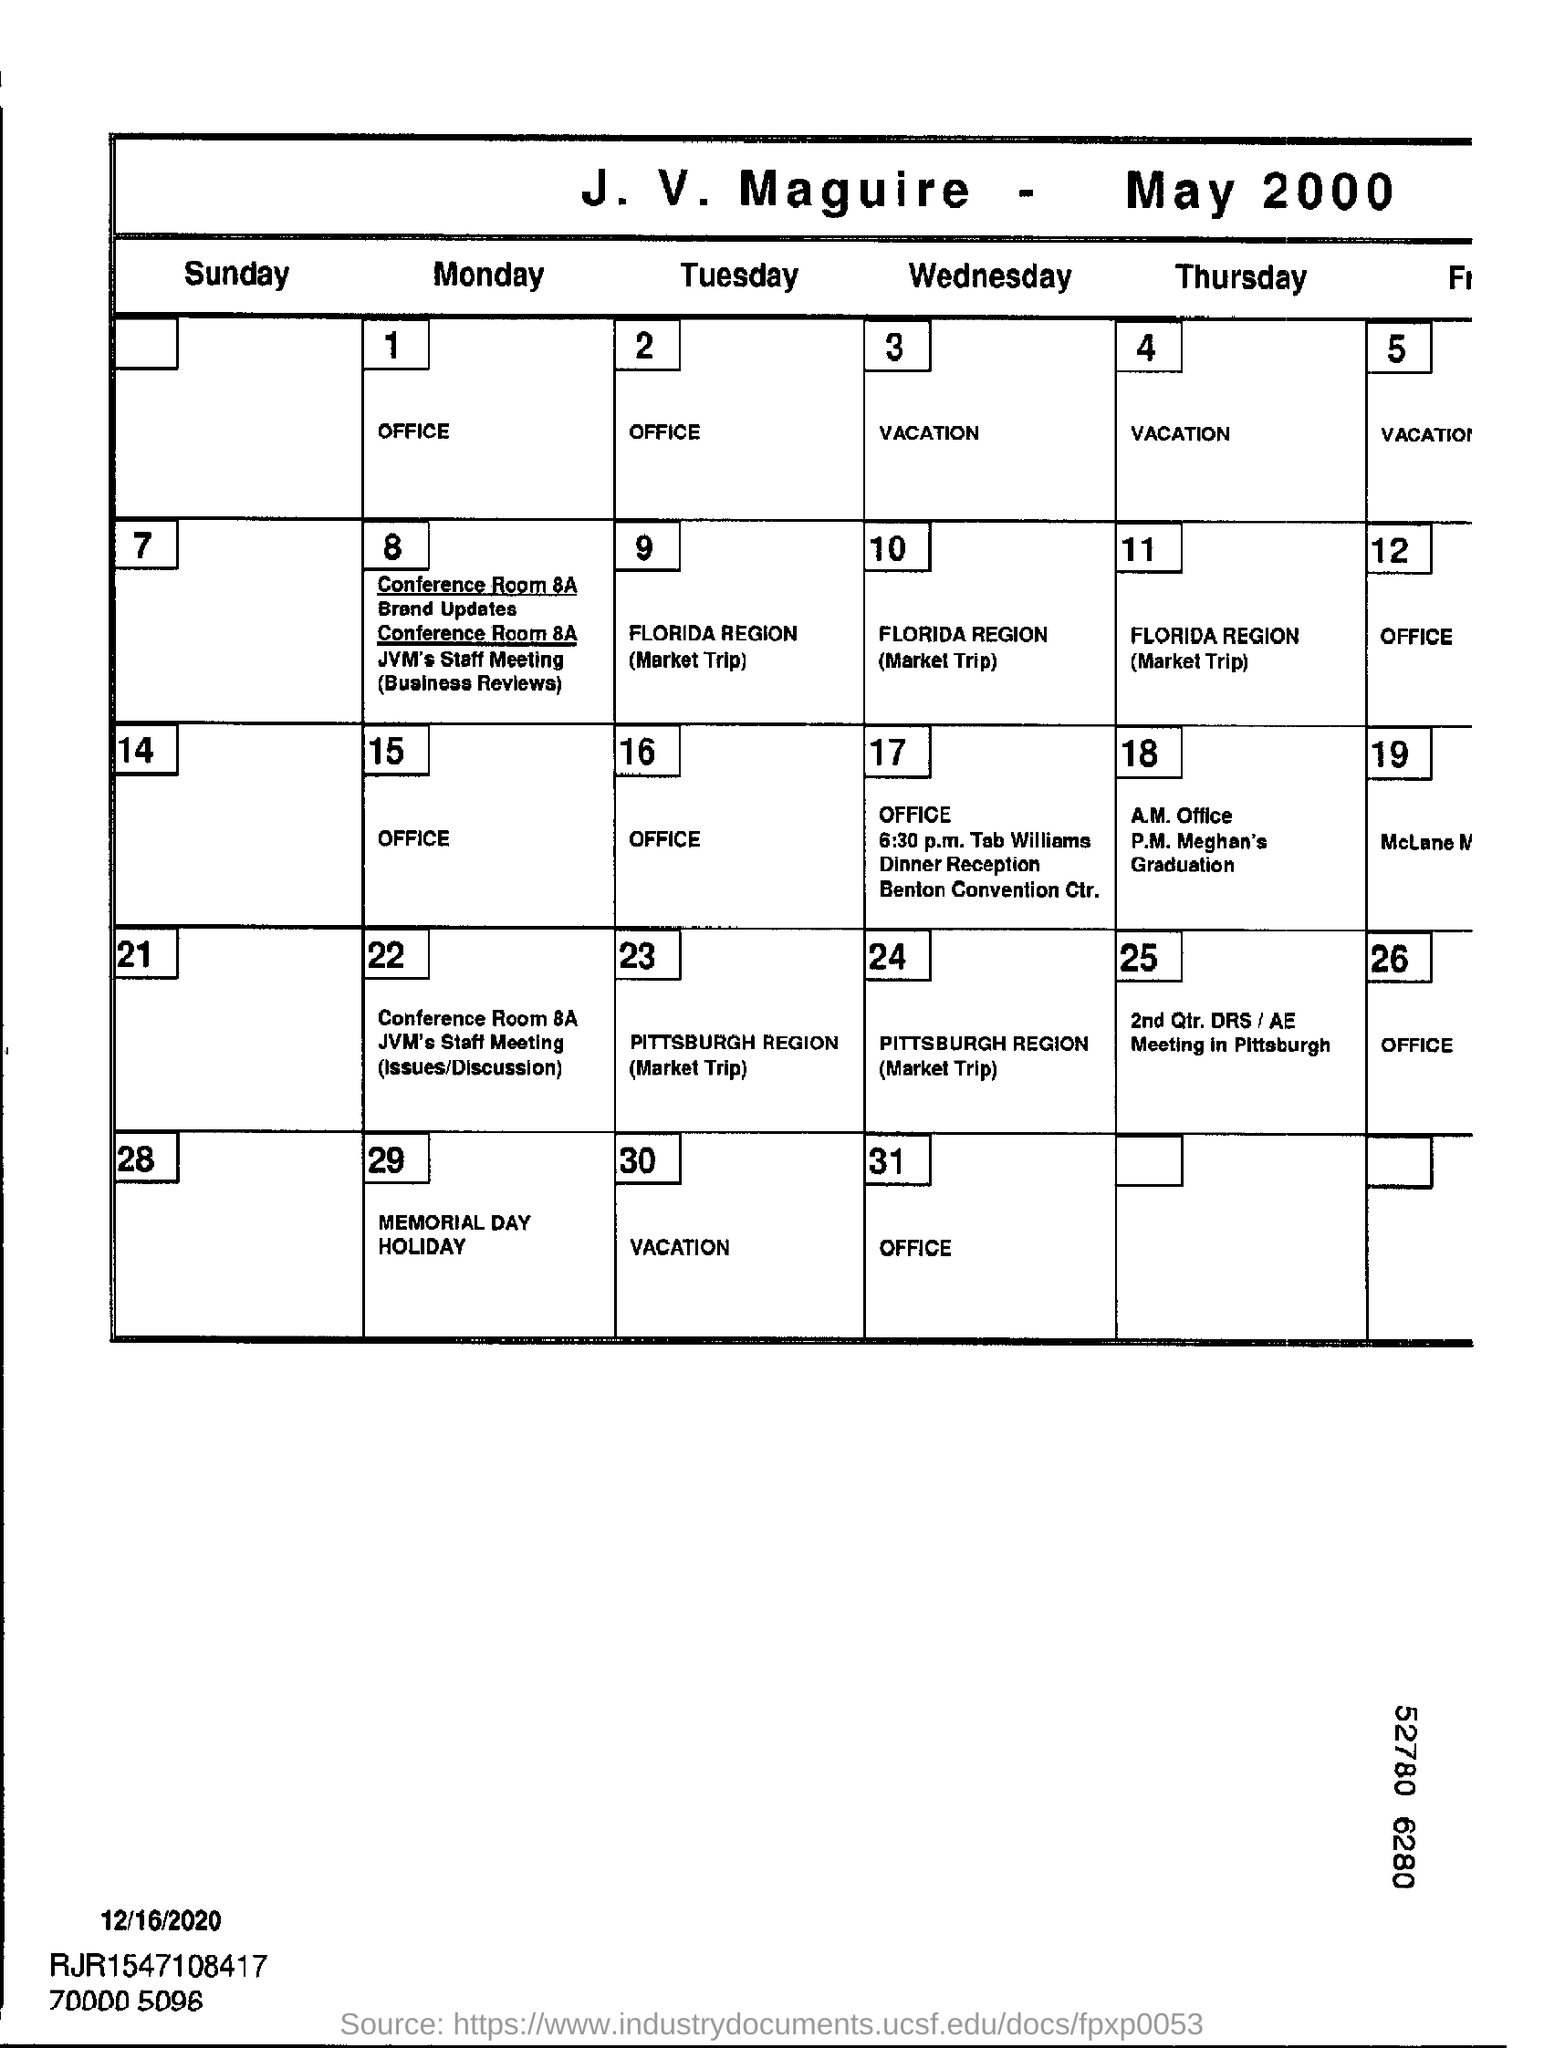Mention a couple of crucial points in this snapshot. The title of the document is "J. V. Maguire - May 2000. 